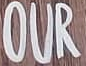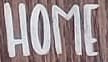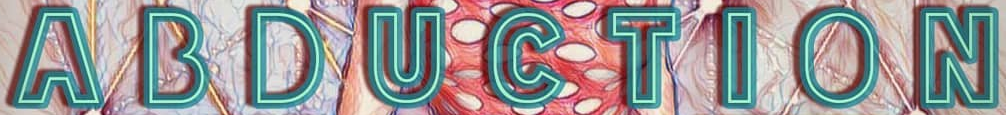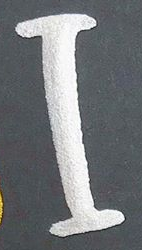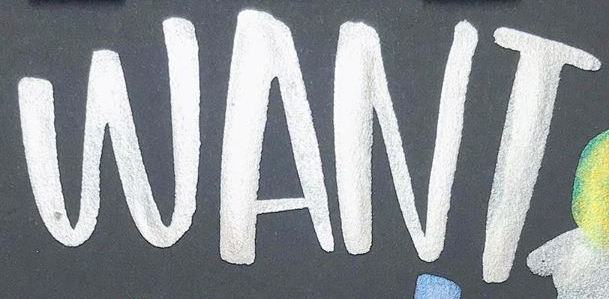Transcribe the words shown in these images in order, separated by a semicolon. OUR; HOME; ABDUCTION; I; WANT 